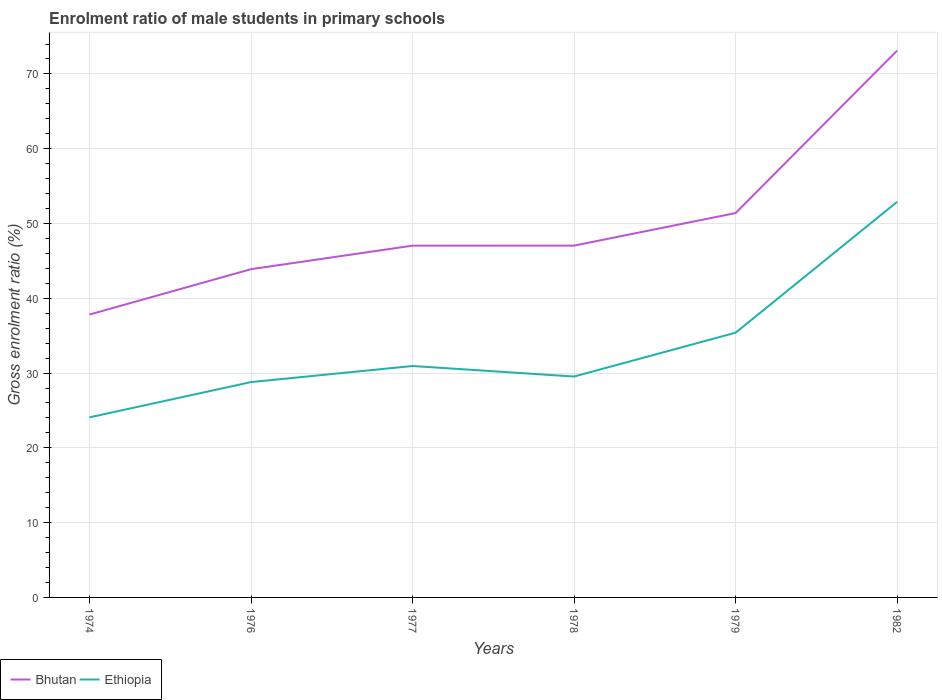How many different coloured lines are there?
Offer a terse response. 2. Is the number of lines equal to the number of legend labels?
Provide a succinct answer. Yes. Across all years, what is the maximum enrolment ratio of male students in primary schools in Ethiopia?
Provide a short and direct response. 24.08. In which year was the enrolment ratio of male students in primary schools in Bhutan maximum?
Your answer should be compact. 1974. What is the total enrolment ratio of male students in primary schools in Bhutan in the graph?
Keep it short and to the point. -9.21. What is the difference between the highest and the second highest enrolment ratio of male students in primary schools in Bhutan?
Offer a terse response. 35.29. Is the enrolment ratio of male students in primary schools in Ethiopia strictly greater than the enrolment ratio of male students in primary schools in Bhutan over the years?
Give a very brief answer. Yes. How many years are there in the graph?
Ensure brevity in your answer.  6. What is the difference between two consecutive major ticks on the Y-axis?
Your answer should be compact. 10. Are the values on the major ticks of Y-axis written in scientific E-notation?
Provide a succinct answer. No. Does the graph contain any zero values?
Your response must be concise. No. Does the graph contain grids?
Ensure brevity in your answer.  Yes. What is the title of the graph?
Offer a very short reply. Enrolment ratio of male students in primary schools. Does "Malaysia" appear as one of the legend labels in the graph?
Your answer should be compact. No. What is the label or title of the Y-axis?
Your response must be concise. Gross enrolment ratio (%). What is the Gross enrolment ratio (%) of Bhutan in 1974?
Offer a terse response. 37.83. What is the Gross enrolment ratio (%) in Ethiopia in 1974?
Your response must be concise. 24.08. What is the Gross enrolment ratio (%) of Bhutan in 1976?
Offer a terse response. 43.89. What is the Gross enrolment ratio (%) of Ethiopia in 1976?
Your answer should be compact. 28.79. What is the Gross enrolment ratio (%) of Bhutan in 1977?
Give a very brief answer. 47.04. What is the Gross enrolment ratio (%) of Ethiopia in 1977?
Your answer should be compact. 30.94. What is the Gross enrolment ratio (%) in Bhutan in 1978?
Offer a very short reply. 47.04. What is the Gross enrolment ratio (%) of Ethiopia in 1978?
Your answer should be compact. 29.54. What is the Gross enrolment ratio (%) in Bhutan in 1979?
Keep it short and to the point. 51.39. What is the Gross enrolment ratio (%) of Ethiopia in 1979?
Your answer should be very brief. 35.4. What is the Gross enrolment ratio (%) of Bhutan in 1982?
Ensure brevity in your answer.  73.12. What is the Gross enrolment ratio (%) in Ethiopia in 1982?
Offer a very short reply. 52.89. Across all years, what is the maximum Gross enrolment ratio (%) in Bhutan?
Offer a terse response. 73.12. Across all years, what is the maximum Gross enrolment ratio (%) in Ethiopia?
Your answer should be very brief. 52.89. Across all years, what is the minimum Gross enrolment ratio (%) in Bhutan?
Your answer should be compact. 37.83. Across all years, what is the minimum Gross enrolment ratio (%) of Ethiopia?
Your answer should be very brief. 24.08. What is the total Gross enrolment ratio (%) of Bhutan in the graph?
Keep it short and to the point. 300.31. What is the total Gross enrolment ratio (%) of Ethiopia in the graph?
Make the answer very short. 201.64. What is the difference between the Gross enrolment ratio (%) of Bhutan in 1974 and that in 1976?
Your answer should be very brief. -6.07. What is the difference between the Gross enrolment ratio (%) in Ethiopia in 1974 and that in 1976?
Offer a very short reply. -4.72. What is the difference between the Gross enrolment ratio (%) in Bhutan in 1974 and that in 1977?
Make the answer very short. -9.21. What is the difference between the Gross enrolment ratio (%) in Ethiopia in 1974 and that in 1977?
Offer a very short reply. -6.87. What is the difference between the Gross enrolment ratio (%) in Bhutan in 1974 and that in 1978?
Offer a terse response. -9.21. What is the difference between the Gross enrolment ratio (%) of Ethiopia in 1974 and that in 1978?
Give a very brief answer. -5.46. What is the difference between the Gross enrolment ratio (%) in Bhutan in 1974 and that in 1979?
Your answer should be very brief. -13.57. What is the difference between the Gross enrolment ratio (%) of Ethiopia in 1974 and that in 1979?
Provide a succinct answer. -11.32. What is the difference between the Gross enrolment ratio (%) in Bhutan in 1974 and that in 1982?
Offer a very short reply. -35.29. What is the difference between the Gross enrolment ratio (%) in Ethiopia in 1974 and that in 1982?
Your response must be concise. -28.82. What is the difference between the Gross enrolment ratio (%) in Bhutan in 1976 and that in 1977?
Give a very brief answer. -3.15. What is the difference between the Gross enrolment ratio (%) of Ethiopia in 1976 and that in 1977?
Your answer should be very brief. -2.15. What is the difference between the Gross enrolment ratio (%) of Bhutan in 1976 and that in 1978?
Give a very brief answer. -3.15. What is the difference between the Gross enrolment ratio (%) in Ethiopia in 1976 and that in 1978?
Provide a short and direct response. -0.74. What is the difference between the Gross enrolment ratio (%) in Bhutan in 1976 and that in 1979?
Provide a short and direct response. -7.5. What is the difference between the Gross enrolment ratio (%) of Ethiopia in 1976 and that in 1979?
Make the answer very short. -6.61. What is the difference between the Gross enrolment ratio (%) in Bhutan in 1976 and that in 1982?
Your response must be concise. -29.23. What is the difference between the Gross enrolment ratio (%) of Ethiopia in 1976 and that in 1982?
Offer a terse response. -24.1. What is the difference between the Gross enrolment ratio (%) of Bhutan in 1977 and that in 1978?
Keep it short and to the point. -0. What is the difference between the Gross enrolment ratio (%) in Ethiopia in 1977 and that in 1978?
Ensure brevity in your answer.  1.41. What is the difference between the Gross enrolment ratio (%) of Bhutan in 1977 and that in 1979?
Give a very brief answer. -4.35. What is the difference between the Gross enrolment ratio (%) of Ethiopia in 1977 and that in 1979?
Offer a terse response. -4.45. What is the difference between the Gross enrolment ratio (%) in Bhutan in 1977 and that in 1982?
Ensure brevity in your answer.  -26.08. What is the difference between the Gross enrolment ratio (%) in Ethiopia in 1977 and that in 1982?
Give a very brief answer. -21.95. What is the difference between the Gross enrolment ratio (%) in Bhutan in 1978 and that in 1979?
Give a very brief answer. -4.35. What is the difference between the Gross enrolment ratio (%) of Ethiopia in 1978 and that in 1979?
Keep it short and to the point. -5.86. What is the difference between the Gross enrolment ratio (%) in Bhutan in 1978 and that in 1982?
Your answer should be very brief. -26.08. What is the difference between the Gross enrolment ratio (%) of Ethiopia in 1978 and that in 1982?
Offer a very short reply. -23.36. What is the difference between the Gross enrolment ratio (%) of Bhutan in 1979 and that in 1982?
Make the answer very short. -21.73. What is the difference between the Gross enrolment ratio (%) in Ethiopia in 1979 and that in 1982?
Offer a very short reply. -17.5. What is the difference between the Gross enrolment ratio (%) of Bhutan in 1974 and the Gross enrolment ratio (%) of Ethiopia in 1976?
Offer a terse response. 9.03. What is the difference between the Gross enrolment ratio (%) of Bhutan in 1974 and the Gross enrolment ratio (%) of Ethiopia in 1977?
Offer a terse response. 6.88. What is the difference between the Gross enrolment ratio (%) in Bhutan in 1974 and the Gross enrolment ratio (%) in Ethiopia in 1978?
Offer a very short reply. 8.29. What is the difference between the Gross enrolment ratio (%) in Bhutan in 1974 and the Gross enrolment ratio (%) in Ethiopia in 1979?
Give a very brief answer. 2.43. What is the difference between the Gross enrolment ratio (%) in Bhutan in 1974 and the Gross enrolment ratio (%) in Ethiopia in 1982?
Offer a very short reply. -15.07. What is the difference between the Gross enrolment ratio (%) of Bhutan in 1976 and the Gross enrolment ratio (%) of Ethiopia in 1977?
Give a very brief answer. 12.95. What is the difference between the Gross enrolment ratio (%) in Bhutan in 1976 and the Gross enrolment ratio (%) in Ethiopia in 1978?
Your answer should be very brief. 14.35. What is the difference between the Gross enrolment ratio (%) in Bhutan in 1976 and the Gross enrolment ratio (%) in Ethiopia in 1979?
Provide a succinct answer. 8.49. What is the difference between the Gross enrolment ratio (%) in Bhutan in 1976 and the Gross enrolment ratio (%) in Ethiopia in 1982?
Make the answer very short. -9. What is the difference between the Gross enrolment ratio (%) of Bhutan in 1977 and the Gross enrolment ratio (%) of Ethiopia in 1978?
Ensure brevity in your answer.  17.5. What is the difference between the Gross enrolment ratio (%) of Bhutan in 1977 and the Gross enrolment ratio (%) of Ethiopia in 1979?
Your answer should be very brief. 11.64. What is the difference between the Gross enrolment ratio (%) in Bhutan in 1977 and the Gross enrolment ratio (%) in Ethiopia in 1982?
Provide a succinct answer. -5.86. What is the difference between the Gross enrolment ratio (%) of Bhutan in 1978 and the Gross enrolment ratio (%) of Ethiopia in 1979?
Make the answer very short. 11.64. What is the difference between the Gross enrolment ratio (%) of Bhutan in 1978 and the Gross enrolment ratio (%) of Ethiopia in 1982?
Ensure brevity in your answer.  -5.85. What is the difference between the Gross enrolment ratio (%) in Bhutan in 1979 and the Gross enrolment ratio (%) in Ethiopia in 1982?
Offer a very short reply. -1.5. What is the average Gross enrolment ratio (%) in Bhutan per year?
Offer a very short reply. 50.05. What is the average Gross enrolment ratio (%) of Ethiopia per year?
Offer a very short reply. 33.61. In the year 1974, what is the difference between the Gross enrolment ratio (%) in Bhutan and Gross enrolment ratio (%) in Ethiopia?
Give a very brief answer. 13.75. In the year 1976, what is the difference between the Gross enrolment ratio (%) of Bhutan and Gross enrolment ratio (%) of Ethiopia?
Provide a short and direct response. 15.1. In the year 1977, what is the difference between the Gross enrolment ratio (%) in Bhutan and Gross enrolment ratio (%) in Ethiopia?
Your answer should be very brief. 16.09. In the year 1978, what is the difference between the Gross enrolment ratio (%) in Bhutan and Gross enrolment ratio (%) in Ethiopia?
Your answer should be very brief. 17.5. In the year 1979, what is the difference between the Gross enrolment ratio (%) in Bhutan and Gross enrolment ratio (%) in Ethiopia?
Keep it short and to the point. 15.99. In the year 1982, what is the difference between the Gross enrolment ratio (%) in Bhutan and Gross enrolment ratio (%) in Ethiopia?
Provide a succinct answer. 20.23. What is the ratio of the Gross enrolment ratio (%) of Bhutan in 1974 to that in 1976?
Keep it short and to the point. 0.86. What is the ratio of the Gross enrolment ratio (%) of Ethiopia in 1974 to that in 1976?
Your response must be concise. 0.84. What is the ratio of the Gross enrolment ratio (%) of Bhutan in 1974 to that in 1977?
Provide a short and direct response. 0.8. What is the ratio of the Gross enrolment ratio (%) in Ethiopia in 1974 to that in 1977?
Your answer should be compact. 0.78. What is the ratio of the Gross enrolment ratio (%) of Bhutan in 1974 to that in 1978?
Give a very brief answer. 0.8. What is the ratio of the Gross enrolment ratio (%) of Ethiopia in 1974 to that in 1978?
Provide a succinct answer. 0.82. What is the ratio of the Gross enrolment ratio (%) in Bhutan in 1974 to that in 1979?
Give a very brief answer. 0.74. What is the ratio of the Gross enrolment ratio (%) in Ethiopia in 1974 to that in 1979?
Your response must be concise. 0.68. What is the ratio of the Gross enrolment ratio (%) of Bhutan in 1974 to that in 1982?
Provide a short and direct response. 0.52. What is the ratio of the Gross enrolment ratio (%) in Ethiopia in 1974 to that in 1982?
Your response must be concise. 0.46. What is the ratio of the Gross enrolment ratio (%) of Bhutan in 1976 to that in 1977?
Offer a very short reply. 0.93. What is the ratio of the Gross enrolment ratio (%) in Ethiopia in 1976 to that in 1977?
Your response must be concise. 0.93. What is the ratio of the Gross enrolment ratio (%) of Bhutan in 1976 to that in 1978?
Your answer should be very brief. 0.93. What is the ratio of the Gross enrolment ratio (%) in Ethiopia in 1976 to that in 1978?
Offer a very short reply. 0.97. What is the ratio of the Gross enrolment ratio (%) of Bhutan in 1976 to that in 1979?
Your response must be concise. 0.85. What is the ratio of the Gross enrolment ratio (%) of Ethiopia in 1976 to that in 1979?
Give a very brief answer. 0.81. What is the ratio of the Gross enrolment ratio (%) in Bhutan in 1976 to that in 1982?
Offer a very short reply. 0.6. What is the ratio of the Gross enrolment ratio (%) in Ethiopia in 1976 to that in 1982?
Provide a succinct answer. 0.54. What is the ratio of the Gross enrolment ratio (%) in Ethiopia in 1977 to that in 1978?
Give a very brief answer. 1.05. What is the ratio of the Gross enrolment ratio (%) of Bhutan in 1977 to that in 1979?
Give a very brief answer. 0.92. What is the ratio of the Gross enrolment ratio (%) of Ethiopia in 1977 to that in 1979?
Offer a terse response. 0.87. What is the ratio of the Gross enrolment ratio (%) in Bhutan in 1977 to that in 1982?
Ensure brevity in your answer.  0.64. What is the ratio of the Gross enrolment ratio (%) of Ethiopia in 1977 to that in 1982?
Provide a short and direct response. 0.58. What is the ratio of the Gross enrolment ratio (%) in Bhutan in 1978 to that in 1979?
Provide a succinct answer. 0.92. What is the ratio of the Gross enrolment ratio (%) of Ethiopia in 1978 to that in 1979?
Provide a succinct answer. 0.83. What is the ratio of the Gross enrolment ratio (%) in Bhutan in 1978 to that in 1982?
Make the answer very short. 0.64. What is the ratio of the Gross enrolment ratio (%) of Ethiopia in 1978 to that in 1982?
Your answer should be compact. 0.56. What is the ratio of the Gross enrolment ratio (%) in Bhutan in 1979 to that in 1982?
Ensure brevity in your answer.  0.7. What is the ratio of the Gross enrolment ratio (%) of Ethiopia in 1979 to that in 1982?
Give a very brief answer. 0.67. What is the difference between the highest and the second highest Gross enrolment ratio (%) of Bhutan?
Provide a short and direct response. 21.73. What is the difference between the highest and the second highest Gross enrolment ratio (%) of Ethiopia?
Provide a succinct answer. 17.5. What is the difference between the highest and the lowest Gross enrolment ratio (%) of Bhutan?
Make the answer very short. 35.29. What is the difference between the highest and the lowest Gross enrolment ratio (%) of Ethiopia?
Offer a terse response. 28.82. 